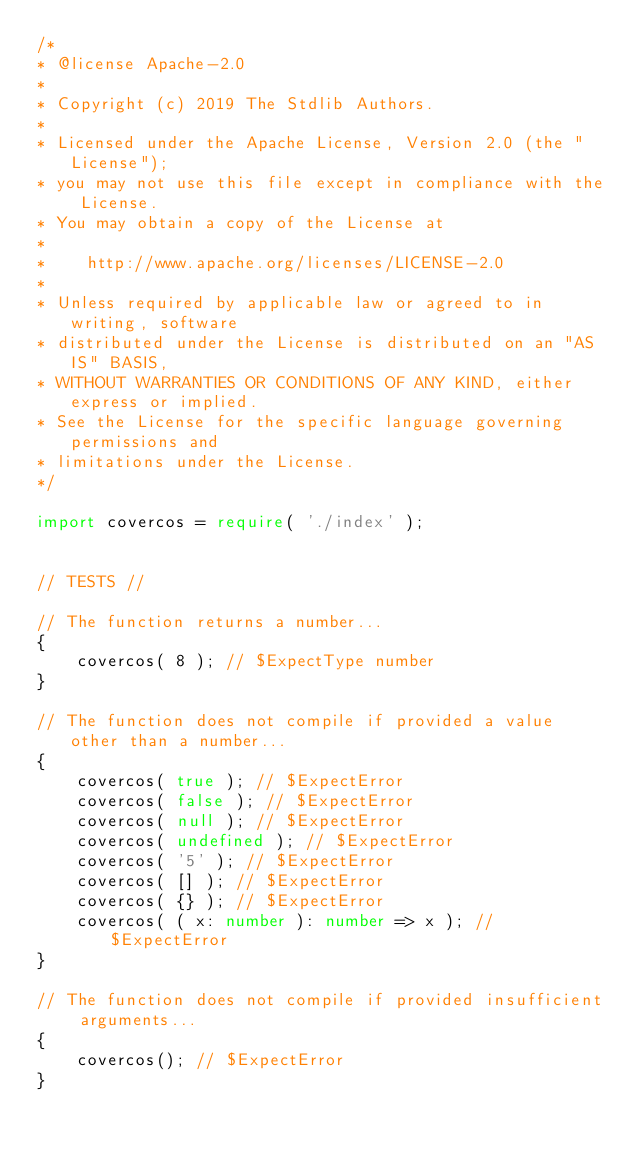<code> <loc_0><loc_0><loc_500><loc_500><_TypeScript_>/*
* @license Apache-2.0
*
* Copyright (c) 2019 The Stdlib Authors.
*
* Licensed under the Apache License, Version 2.0 (the "License");
* you may not use this file except in compliance with the License.
* You may obtain a copy of the License at
*
*    http://www.apache.org/licenses/LICENSE-2.0
*
* Unless required by applicable law or agreed to in writing, software
* distributed under the License is distributed on an "AS IS" BASIS,
* WITHOUT WARRANTIES OR CONDITIONS OF ANY KIND, either express or implied.
* See the License for the specific language governing permissions and
* limitations under the License.
*/

import covercos = require( './index' );


// TESTS //

// The function returns a number...
{
	covercos( 8 ); // $ExpectType number
}

// The function does not compile if provided a value other than a number...
{
	covercos( true ); // $ExpectError
	covercos( false ); // $ExpectError
	covercos( null ); // $ExpectError
	covercos( undefined ); // $ExpectError
	covercos( '5' ); // $ExpectError
	covercos( [] ); // $ExpectError
	covercos( {} ); // $ExpectError
	covercos( ( x: number ): number => x ); // $ExpectError
}

// The function does not compile if provided insufficient arguments...
{
	covercos(); // $ExpectError
}
</code> 